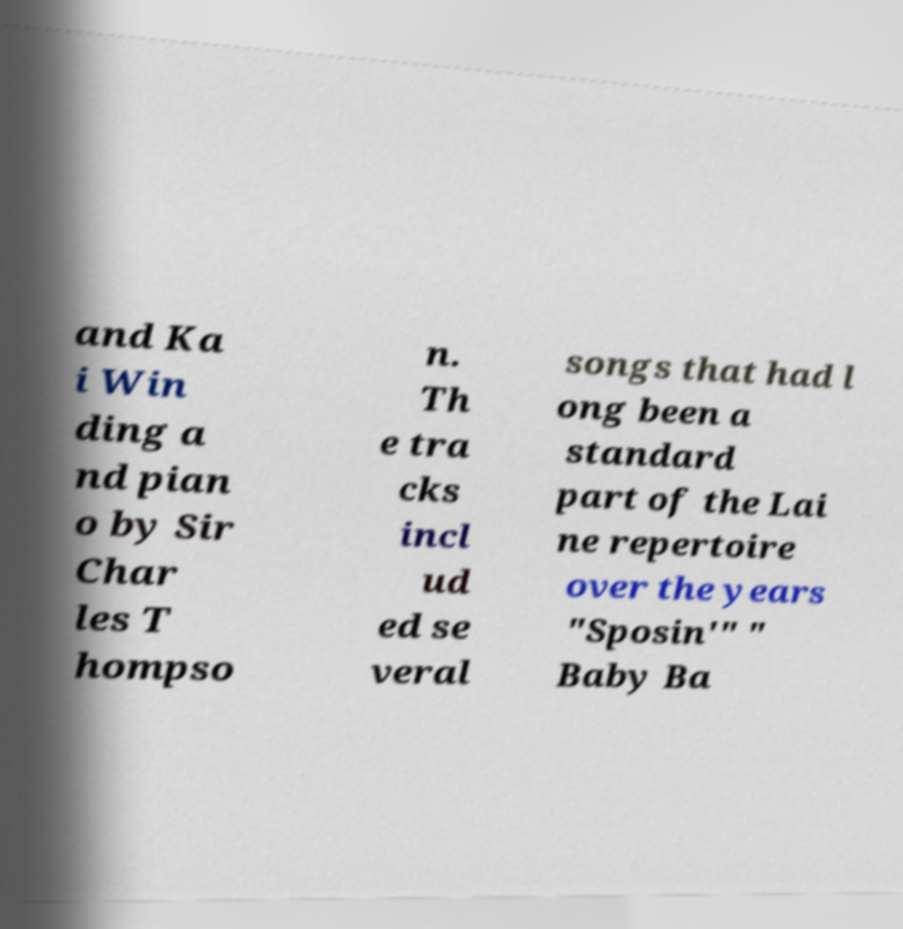Please read and relay the text visible in this image. What does it say? and Ka i Win ding a nd pian o by Sir Char les T hompso n. Th e tra cks incl ud ed se veral songs that had l ong been a standard part of the Lai ne repertoire over the years "Sposin'" " Baby Ba 